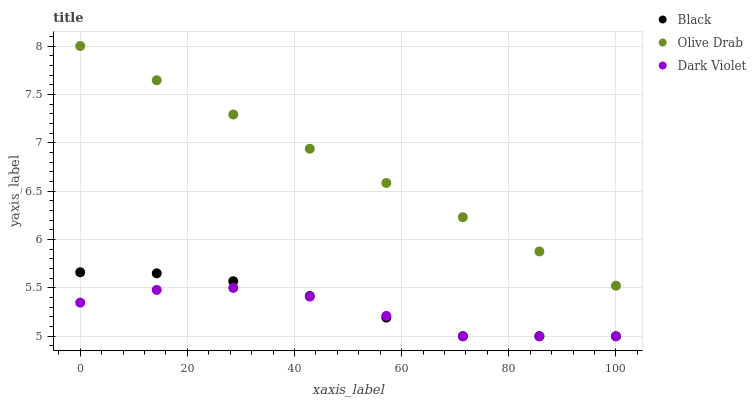Does Dark Violet have the minimum area under the curve?
Answer yes or no. Yes. Does Olive Drab have the maximum area under the curve?
Answer yes or no. Yes. Does Olive Drab have the minimum area under the curve?
Answer yes or no. No. Does Dark Violet have the maximum area under the curve?
Answer yes or no. No. Is Olive Drab the smoothest?
Answer yes or no. Yes. Is Dark Violet the roughest?
Answer yes or no. Yes. Is Dark Violet the smoothest?
Answer yes or no. No. Is Olive Drab the roughest?
Answer yes or no. No. Does Black have the lowest value?
Answer yes or no. Yes. Does Olive Drab have the lowest value?
Answer yes or no. No. Does Olive Drab have the highest value?
Answer yes or no. Yes. Does Dark Violet have the highest value?
Answer yes or no. No. Is Black less than Olive Drab?
Answer yes or no. Yes. Is Olive Drab greater than Dark Violet?
Answer yes or no. Yes. Does Black intersect Dark Violet?
Answer yes or no. Yes. Is Black less than Dark Violet?
Answer yes or no. No. Is Black greater than Dark Violet?
Answer yes or no. No. Does Black intersect Olive Drab?
Answer yes or no. No. 